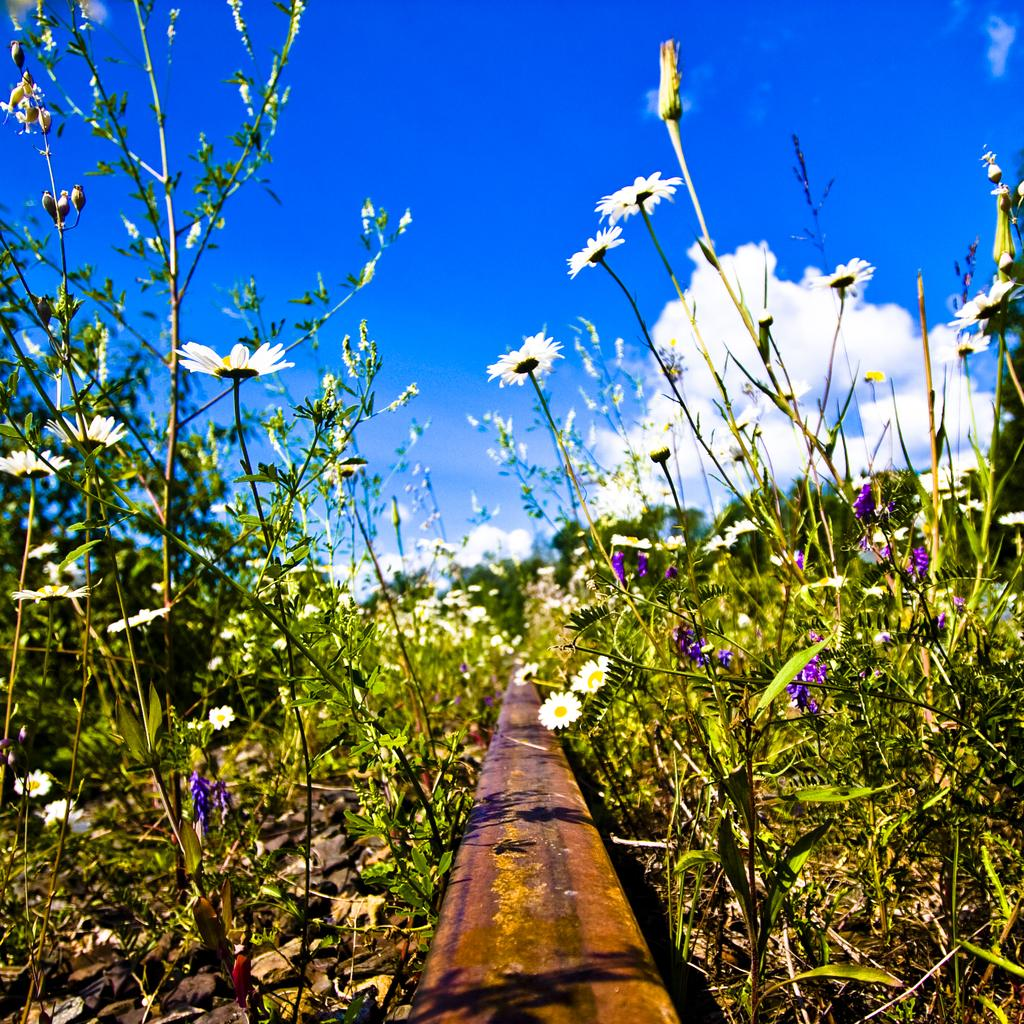What type of plants are in the image? There are plants in the image. What can be observed on the plants? There are flowers on the plants. What part of the natural environment is visible in the image? The sky is visible in the image. How would you describe the sky in the image? The sky appears to be cloudy. What type of juice can be seen being poured from a brick in the image? There is no juice or brick present in the image. 